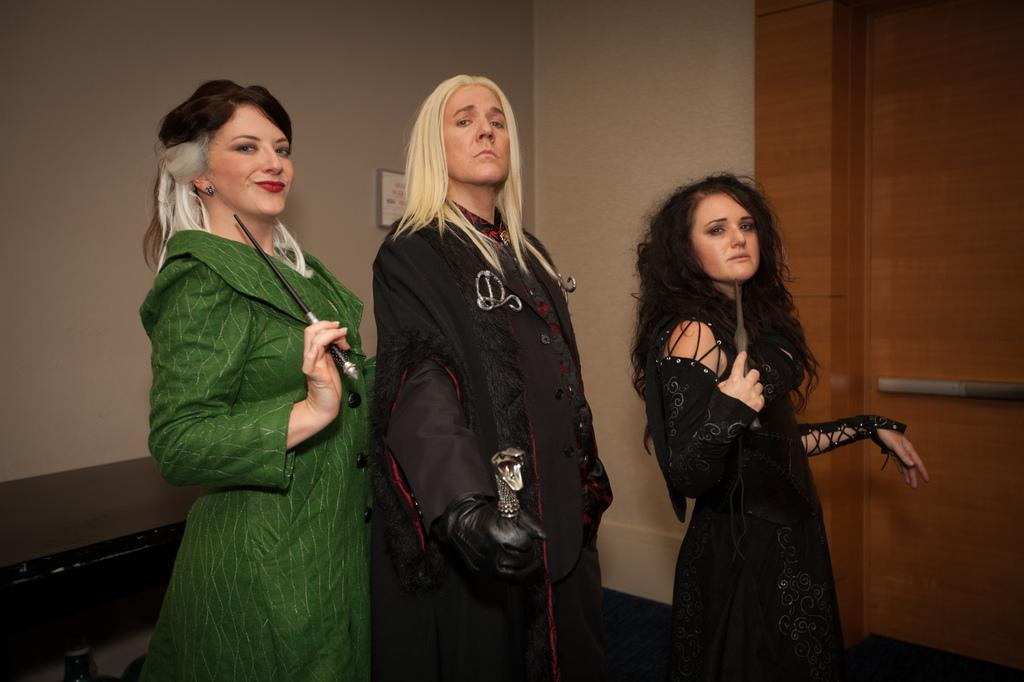How many people are in the image? There are three persons in the image. What are the persons doing in the image? The persons are standing in the image. What are the persons holding in the image? The persons are holding objects in the image. What can be seen in the background of the image? There is a wall in the background of the image. What language are the persons speaking in the image? The provided facts do not mention any language being spoken in the image. Can you tell me the color of the orange in the image? There is no orange present in the image. 